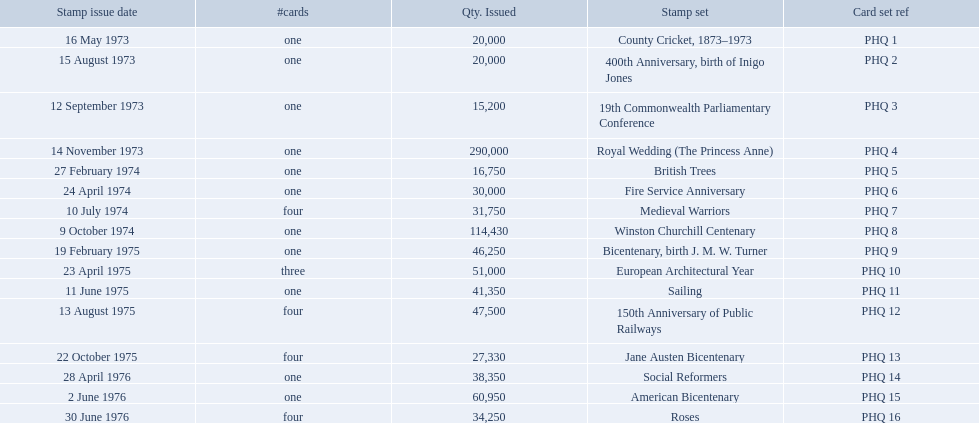What are all of the stamp sets? County Cricket, 1873–1973, 400th Anniversary, birth of Inigo Jones, 19th Commonwealth Parliamentary Conference, Royal Wedding (The Princess Anne), British Trees, Fire Service Anniversary, Medieval Warriors, Winston Churchill Centenary, Bicentenary, birth J. M. W. Turner, European Architectural Year, Sailing, 150th Anniversary of Public Railways, Jane Austen Bicentenary, Social Reformers, American Bicentenary, Roses. Which of these sets has three cards in it? European Architectural Year. 